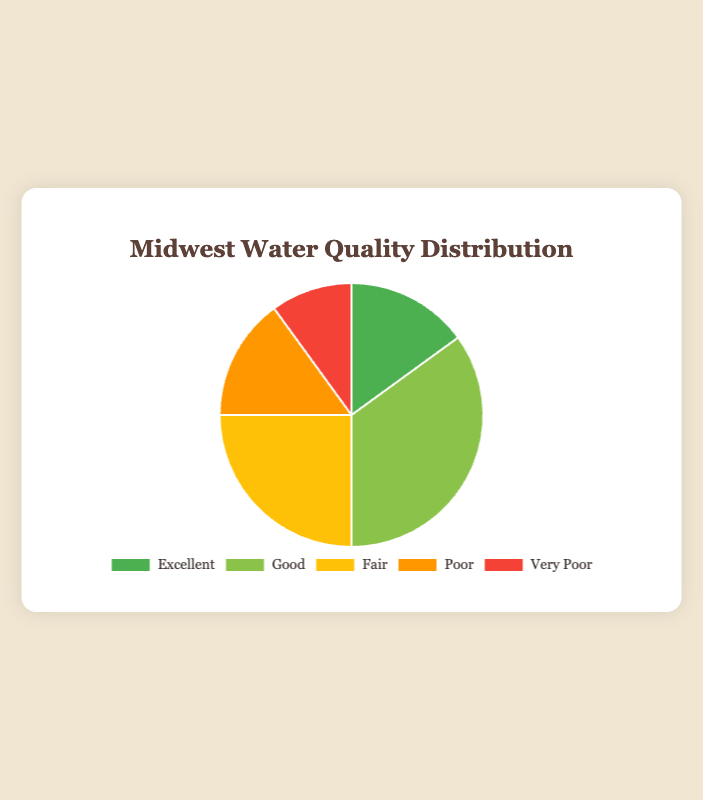What percentage of the water quality in the Midwest is rated as 'Excellent' compared to 'Poor'? To find the percentage comparison, we look at the data points for 'Excellent' and 'Poor'. 'Excellent' is 15% and 'Poor' is 15%. Therefore, the percentage comparison of 'Excellent' to 'Poor' is 15% to 15%.
Answer: 15% to 15% Which category has the highest percentage of water quality distribution in the Midwest? Among the given categories, 'Good' has the highest value of 35%.
Answer: Good What is the total percentage of water quality that is rated as either 'Excellent' or 'Very Poor'? Sum the percentages for 'Excellent' and 'Very Poor': 15% (Excellent) + 10% (Very Poor) = 25%.
Answer: 25% How does the percentage of 'Fair' water quality compare to 'Very Poor' water quality? 'Fair' has a percentage of 25%, while 'Very Poor' has 10%. Comparing these, 'Fair' is 15% higher than 'Very Poor'.
Answer: 15% higher What is the average percentage of the water quality categories in the Midwest? To find the average, sum all the percentages and divide by the number of categories: (15 + 35 + 25 + 15 + 10)/5 = 20%.
Answer: 20% What is the combined percentage of water quality rated as 'Poor' and 'Fair'? Add the percentages for 'Poor' and 'Fair': 15% (Poor) + 25% (Fair) = 40%.
Answer: 40% If you were to visually describe the color representing the category with the least water quality, what color would it be? According to the legend, 'Very Poor' has the least value of 10% and is represented by the color red.
Answer: Red Which categories have equal percentages, and what are those percentages? 'Excellent' and 'Poor' both have a percentage of 15%.
Answer: Excellent and Poor, 15% If 'Good' water quality dropped by 10%, what would be the new percentage of 'Good' and the sum of all categories? If 'Good' drops by 10%, it becomes 25% (35% - 10%). The sum of all categories would then be: 15% (Excellent) + 25% (Good) + 25% (Fair) + 15% (Poor) + 10% (Very Poor) = 90%.
Answer: 25%, 90% What is the difference between the highest and the lowest percentages of water quality distribution? The highest percentage is 'Good' at 35%, and the lowest is 'Very Poor' at 10%. The difference is 35% - 10% = 25%.
Answer: 25% 